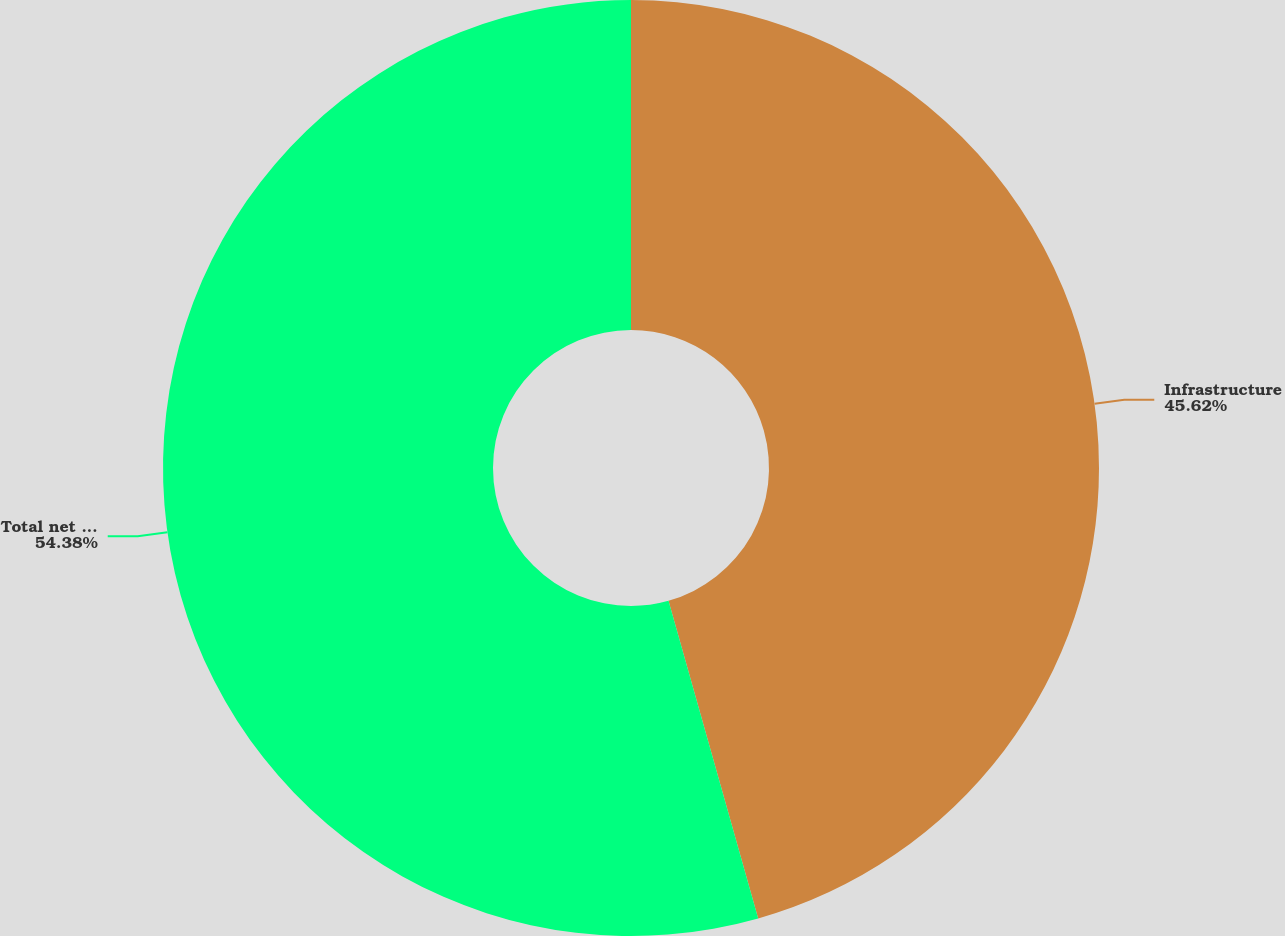Convert chart. <chart><loc_0><loc_0><loc_500><loc_500><pie_chart><fcel>Infrastructure<fcel>Total net product revenues<nl><fcel>45.62%<fcel>54.38%<nl></chart> 